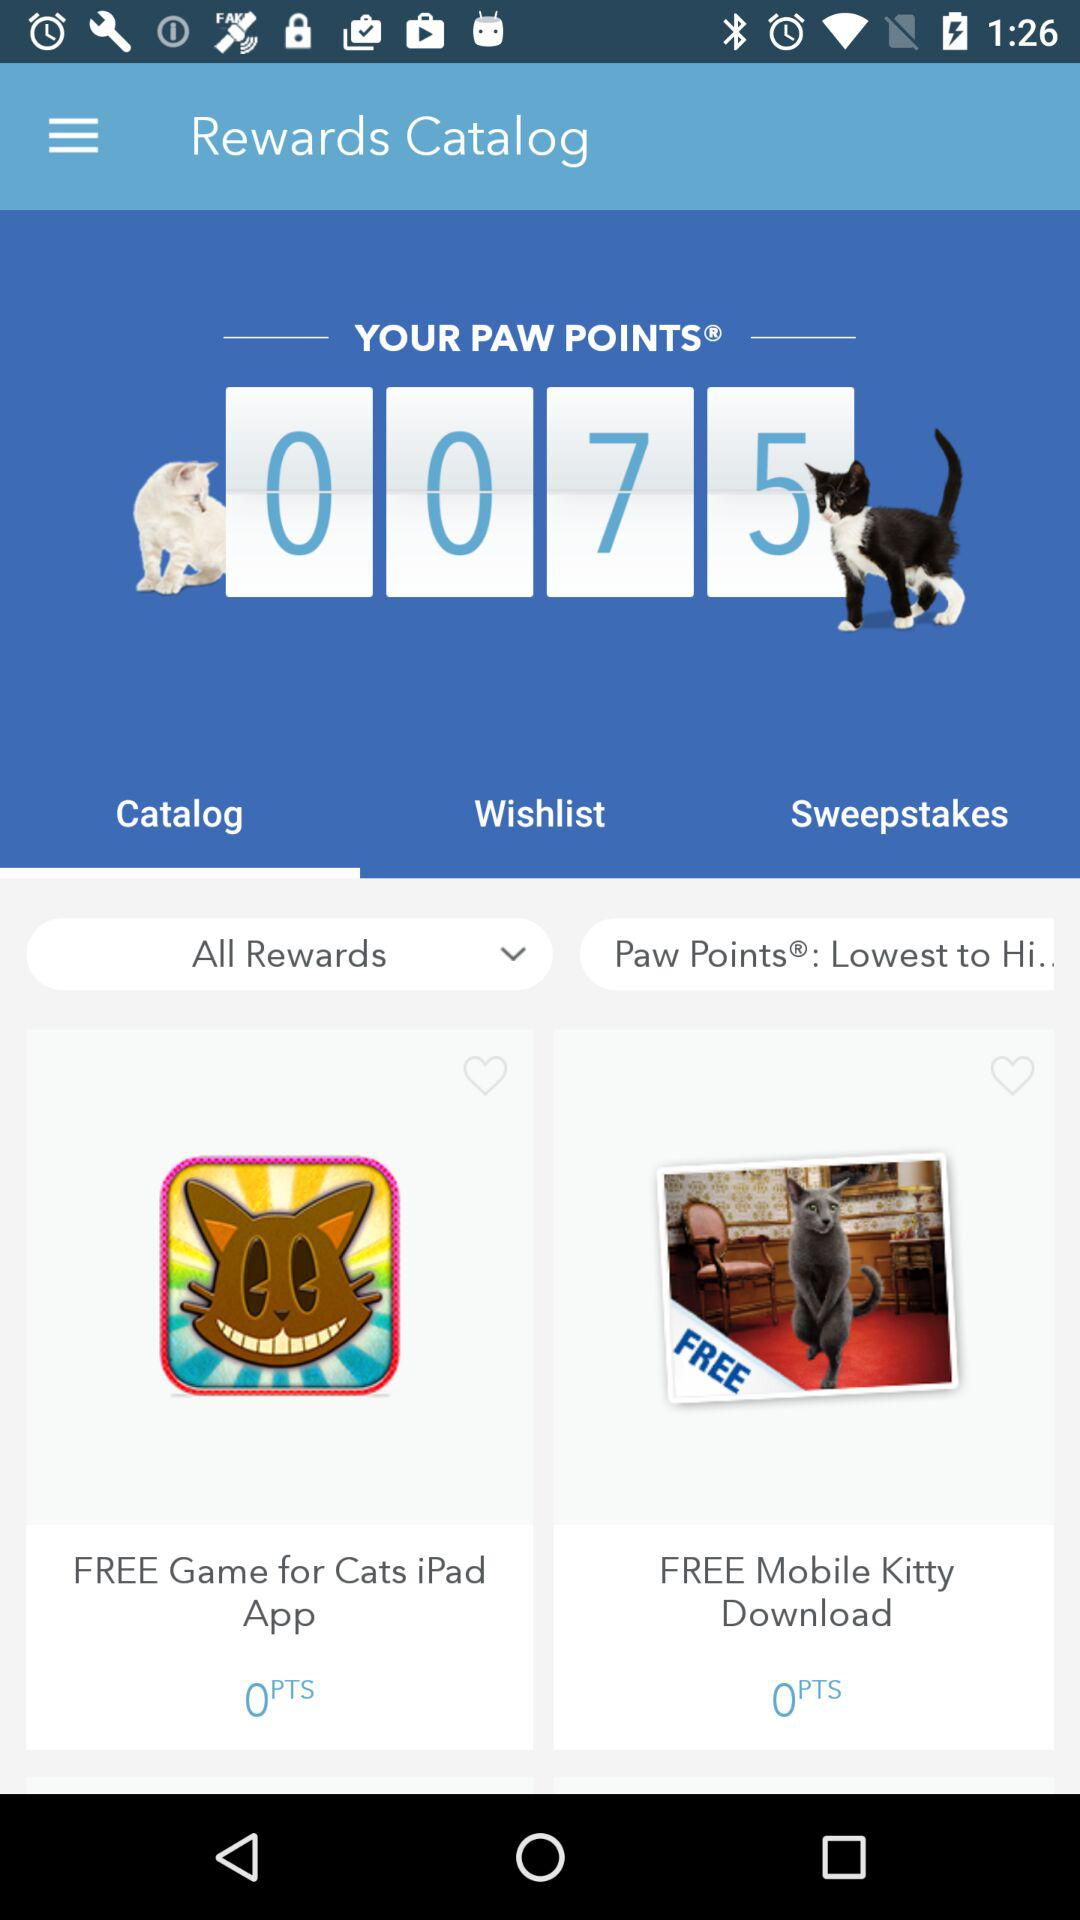What are my paw points? Your paw points are 75. 